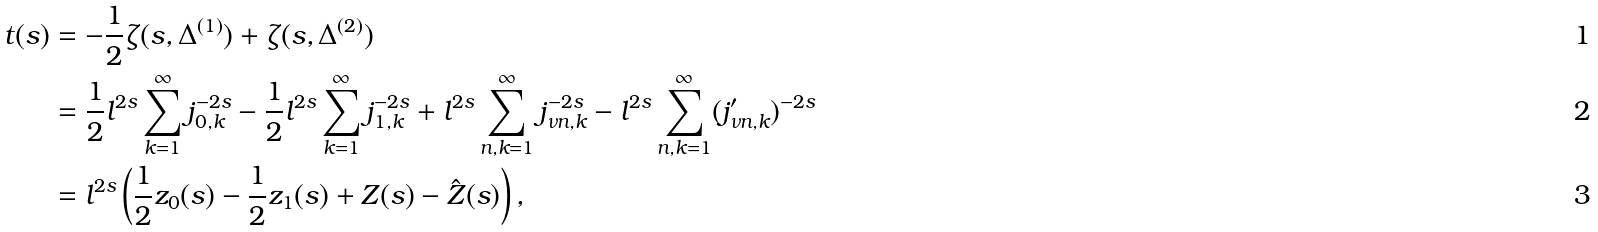<formula> <loc_0><loc_0><loc_500><loc_500>t ( s ) & = - \frac { 1 } { 2 } \zeta ( s , \Delta ^ { ( 1 ) } ) + \zeta ( s , \Delta ^ { ( 2 ) } ) \\ & = \frac { 1 } { 2 } l ^ { 2 s } \sum _ { k = 1 } ^ { \infty } j _ { 0 , k } ^ { - 2 s } - \frac { 1 } { 2 } l ^ { 2 s } \sum _ { k = 1 } ^ { \infty } j _ { 1 , k } ^ { - 2 s } + l ^ { 2 s } \sum _ { n , k = 1 } ^ { \infty } j _ { \nu n , k } ^ { - 2 s } - l ^ { 2 s } \sum _ { n , k = 1 } ^ { \infty } ( j _ { \nu n , k } ^ { \prime } ) ^ { - 2 s } \\ & = l ^ { 2 s } \left ( \frac { 1 } { 2 } z _ { 0 } ( s ) - \frac { 1 } { 2 } z _ { 1 } ( s ) + Z ( s ) - \hat { Z } ( s ) \right ) ,</formula> 